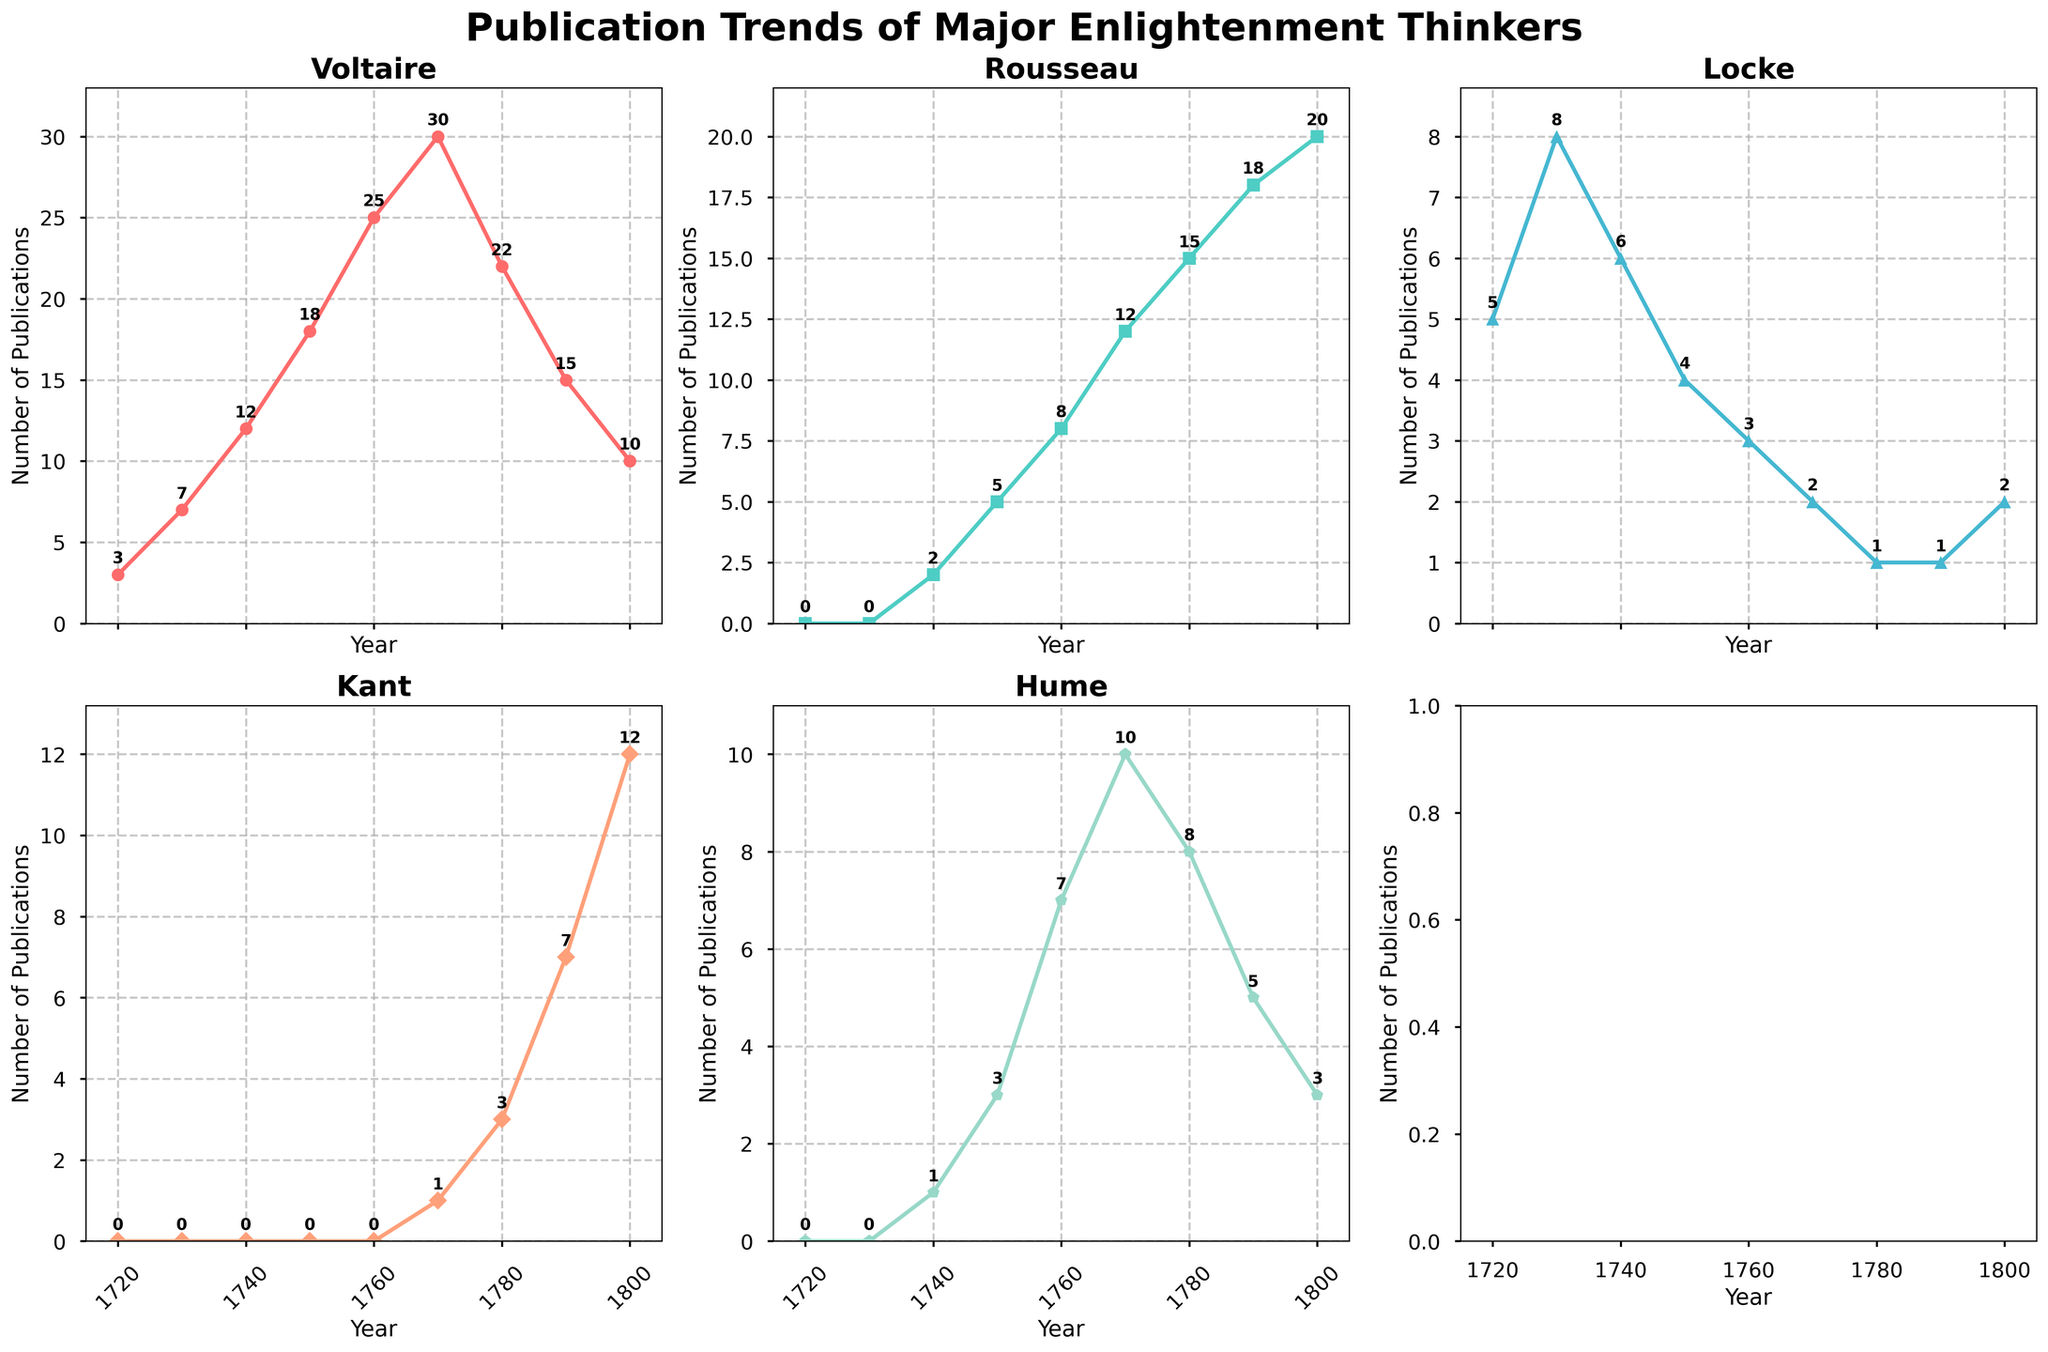What's the main title of the figure? The title of the figure is prominently displayed at the top in large, bold font. It serves as a concise summary of what the chart depicts.
Answer: Publication Trends of Major Enlightenment Thinkers How many thinkers are displayed in the figure? Each subplot represents one thinker, and there are five subplots laid out in a 2 by 3 grid. Hence, five thinkers are displayed.
Answer: Five Which thinker shows the highest number of publications around 1760? By referring to the subplots and looking at the values around 1760, we see that Voltaire has the highest peak compared to others.
Answer: Voltaire What range of years does the figure cover? The x-axis of each subplot ranges from 1720 to 1800, which covers the publication trends over this period.
Answer: 1720 to 1800 How did Rousseau's publications trend between 1740 and 1790? From the subplot for Rousseau, the number of publications increased from 2 in 1740 to 18 in 1790. The trend is generally increasing during this period.
Answer: Increasing For which thinker did the number of publications increase the most between 1740 and 1760? By examining the subplots and comparing the increases in publication numbers, Voltaire's publications increased from 12 to 25, suggesting an increase of 13. This is larger compared to the other thinkers.
Answer: Voltaire Which thinker had the least number of publications in 1780? By looking at the subplots for the year 1780, Locke has only 1 publication, which is the least among the displayed thinkers.
Answer: Locke What is the approximate average number of publications for Kant between 1770 and 1800? For Kant, the publication numbers between 1770 and 1800 are 1, 3, 7, and 12. Adding these, we get 23. There are 4 values, so the average is 23/4.
Answer: 5.75 Did Hume's publications ever decrease over the displayed period? By observing Hume's subplot, there is an initial increase in publications, but from 1780 to 1800, there is a noticeable decline from 10 to 3.
Answer: Yes Whose publications peaked earliest, and in what year? By looking at the peaks of each subplot, Voltaire's publications peak at 30 in the year 1770, which is earlier than Rousseau's later peak years.
Answer: Voltaire in 1770 